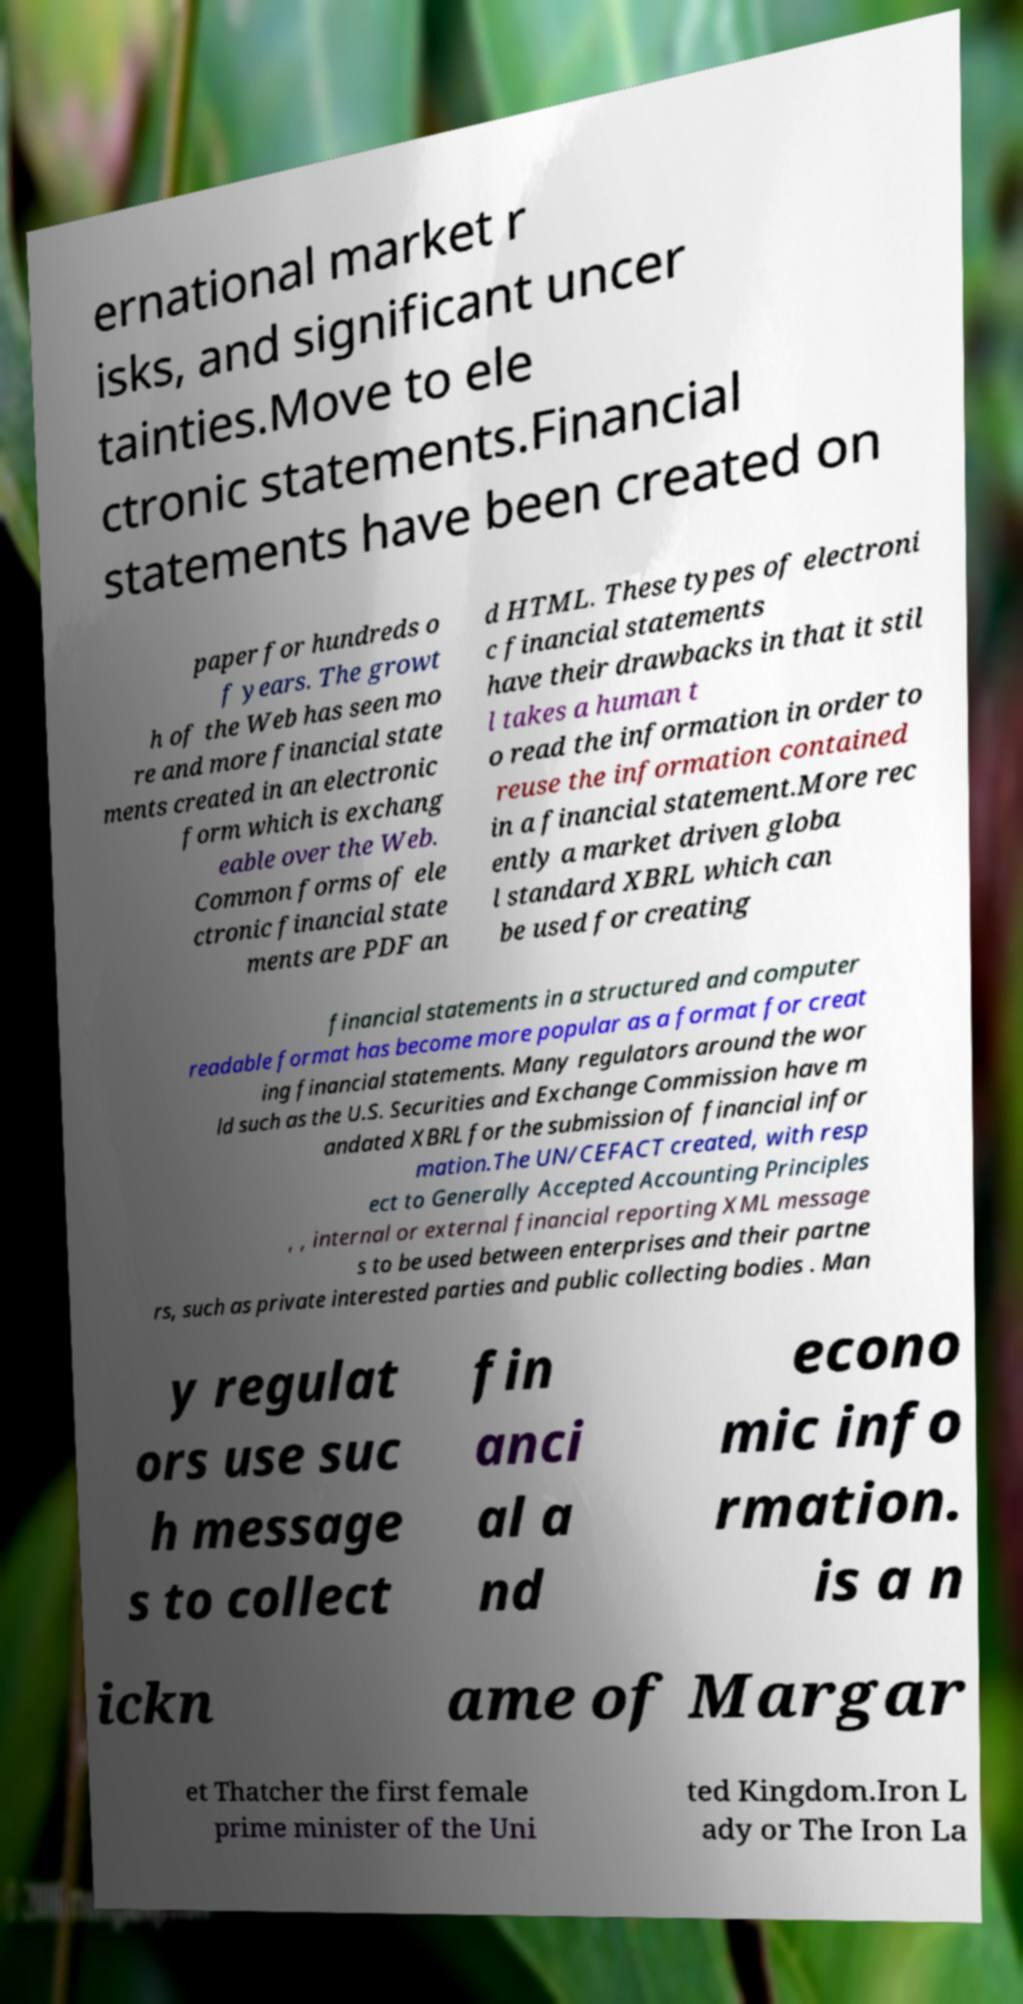For documentation purposes, I need the text within this image transcribed. Could you provide that? ernational market r isks, and significant uncer tainties.Move to ele ctronic statements.Financial statements have been created on paper for hundreds o f years. The growt h of the Web has seen mo re and more financial state ments created in an electronic form which is exchang eable over the Web. Common forms of ele ctronic financial state ments are PDF an d HTML. These types of electroni c financial statements have their drawbacks in that it stil l takes a human t o read the information in order to reuse the information contained in a financial statement.More rec ently a market driven globa l standard XBRL which can be used for creating financial statements in a structured and computer readable format has become more popular as a format for creat ing financial statements. Many regulators around the wor ld such as the U.S. Securities and Exchange Commission have m andated XBRL for the submission of financial infor mation.The UN/CEFACT created, with resp ect to Generally Accepted Accounting Principles , , internal or external financial reporting XML message s to be used between enterprises and their partne rs, such as private interested parties and public collecting bodies . Man y regulat ors use suc h message s to collect fin anci al a nd econo mic info rmation. is a n ickn ame of Margar et Thatcher the first female prime minister of the Uni ted Kingdom.Iron L ady or The Iron La 